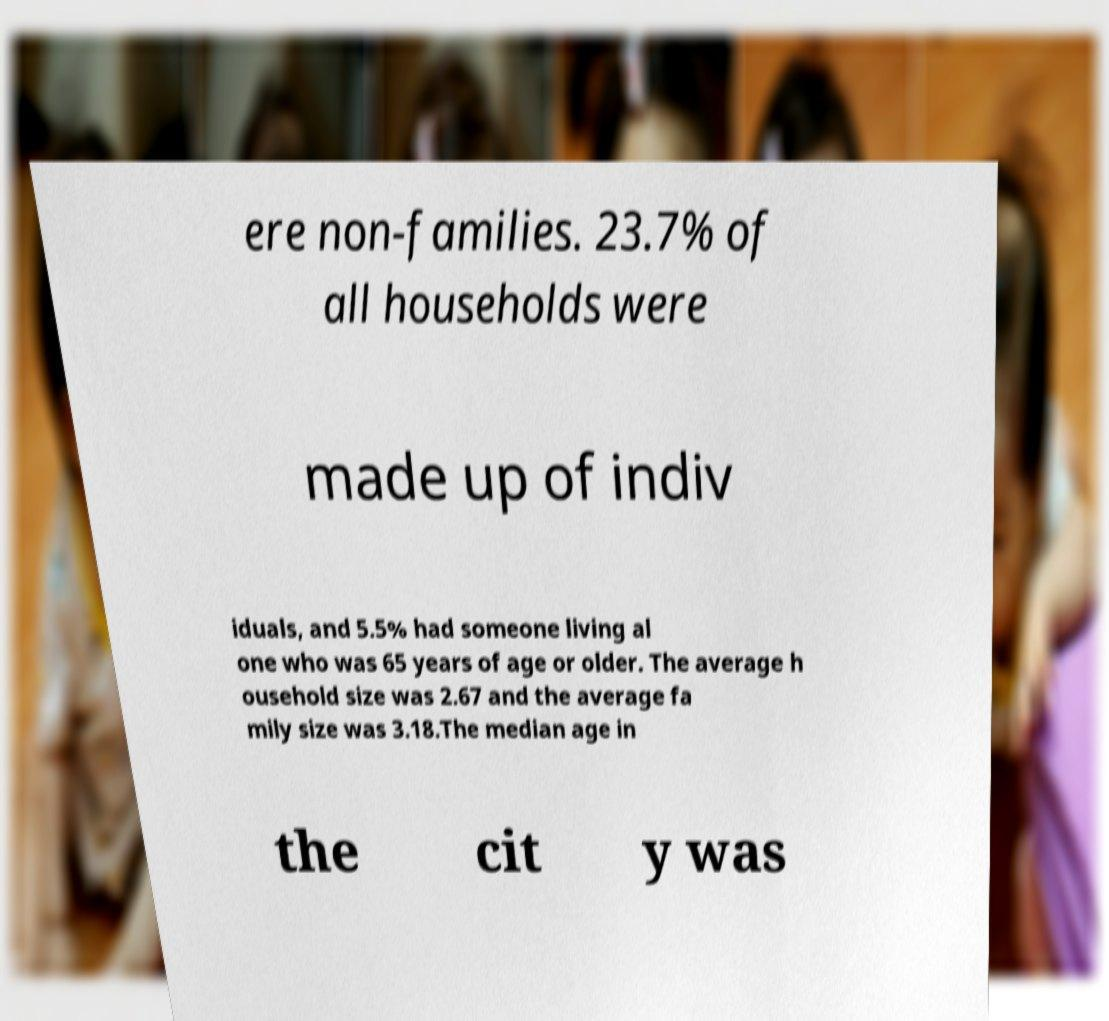Could you assist in decoding the text presented in this image and type it out clearly? ere non-families. 23.7% of all households were made up of indiv iduals, and 5.5% had someone living al one who was 65 years of age or older. The average h ousehold size was 2.67 and the average fa mily size was 3.18.The median age in the cit y was 